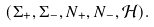<formula> <loc_0><loc_0><loc_500><loc_500>( \Sigma _ { + } , \Sigma _ { - } , N _ { + } , N _ { - } , \mathcal { H } ) .</formula> 